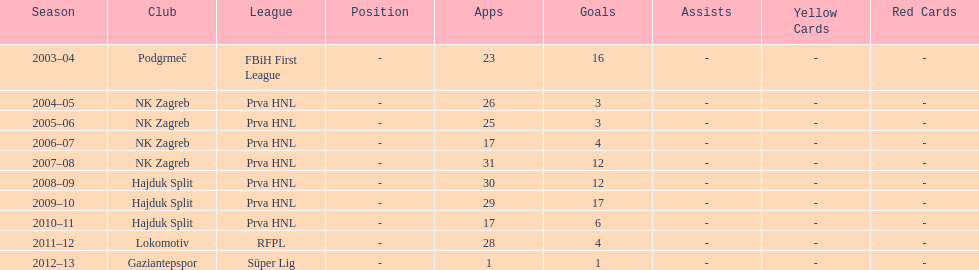After scoring against bulgaria in zenica, ibricic also scored against this team in a 7-0 victory in zenica less then a month after the friendly match against bulgaria. Estonia. 